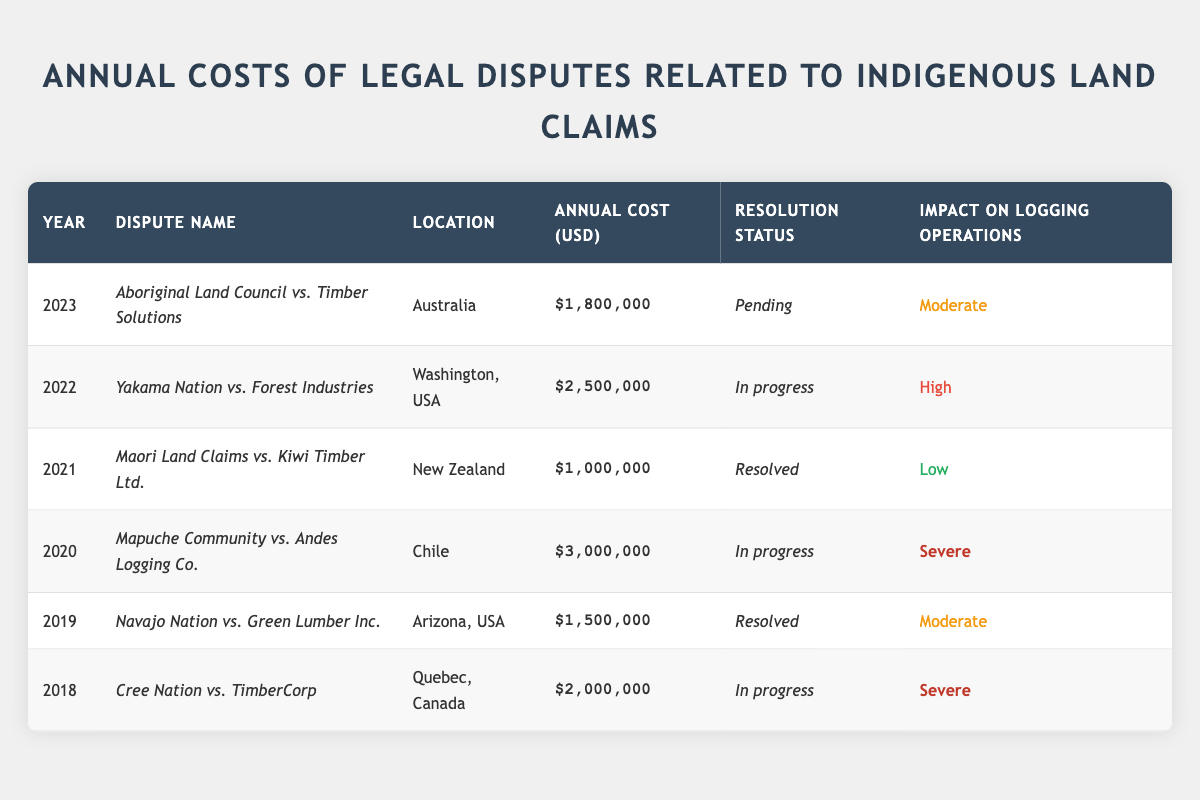What is the annual cost of the dispute between the Cree Nation and TimberCorp? The table lists the annual cost for the dispute, which is specifically provided as $2,000,000.
Answer: $2,000,000 Which dispute had the highest annual cost? Reviewing the table, the Mapuche Community vs. Andes Logging Co. dispute has the highest annual cost of $3,000,000.
Answer: $3,000,000 How many disputes are currently in progress? The table indicates three disputes labeled as "In progress": Cree Nation vs. TimberCorp, Mapuche Community vs. Andes Logging Co., and Yakama Nation vs. Forest Industries.
Answer: 3 What was the impact on logging operations for the dispute involving the Maori Land Claims? The table shows that the impact on logging operations for the Maori Land Claims vs. Kiwi Timber Ltd. is classified as "Low."
Answer: Low Calculate the total annual cost for all resolved disputes. The resolved disputes are the ones involving the Navajo Nation ($1,500,000) and Maori Land Claims ($1,000,000). Summing these gives: $1,500,000 + $1,000,000 = $2,500,000.
Answer: $2,500,000 True or False: The dispute between the Aboriginal Land Council and Timber Solutions has a "Severe" impact on logging operations. By checking the table, the impact on logging operations for this dispute is categorized as "Moderate," hence it is false.
Answer: False How does the total cost of disputes in 2023 compare to the total cost in 2018? In 2023, the cost is $1,800,000 and in 2018 it is $2,000,000. Since $1,800,000 is less than $2,000,000, it shows a decrease.
Answer: Decrease Which location has disputes that have a "Severe" impact? According to the table, the disputes involving the Cree Nation vs. TimberCorp and the Mapuche Community vs. Andes Logging Co. both have a "Severe" impact and are located in Canada and Chile, respectively.
Answer: Quebec, Canada and Chile What is the average annual cost of all disputes? To find this, total the annual costs: $2,000,000 + $1,500,000 + $3,000,000 + $1,000,000 + $2,500,000 + $1,800,000 = $12,800,000. There are 6 disputes, so average cost = $12,800,000 / 6 = $2,133,333.33.
Answer: $2,133,333.33 How many disputes had a moderate impact classified as "Moderate"? The table shows disputes with moderate impact are the ones involving the Navajo Nation and Aboriginal Land Council, totaling 2 disputes.
Answer: 2 